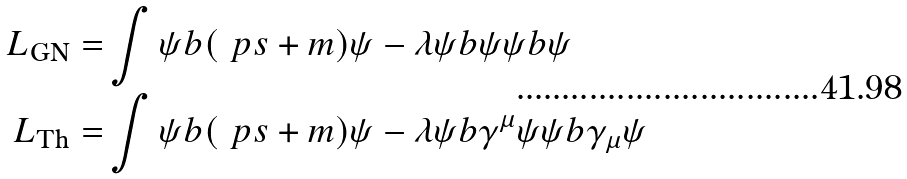<formula> <loc_0><loc_0><loc_500><loc_500>L _ { \text {GN} } = & \int \psi b ( \ p s + m ) \psi - \lambda \psi b \psi \psi b \psi \\ L _ { \text {Th} } = & \int \psi b ( \ p s + m ) \psi - \lambda \psi b \gamma ^ { \mu } \psi \psi b \gamma _ { \mu } \psi</formula> 